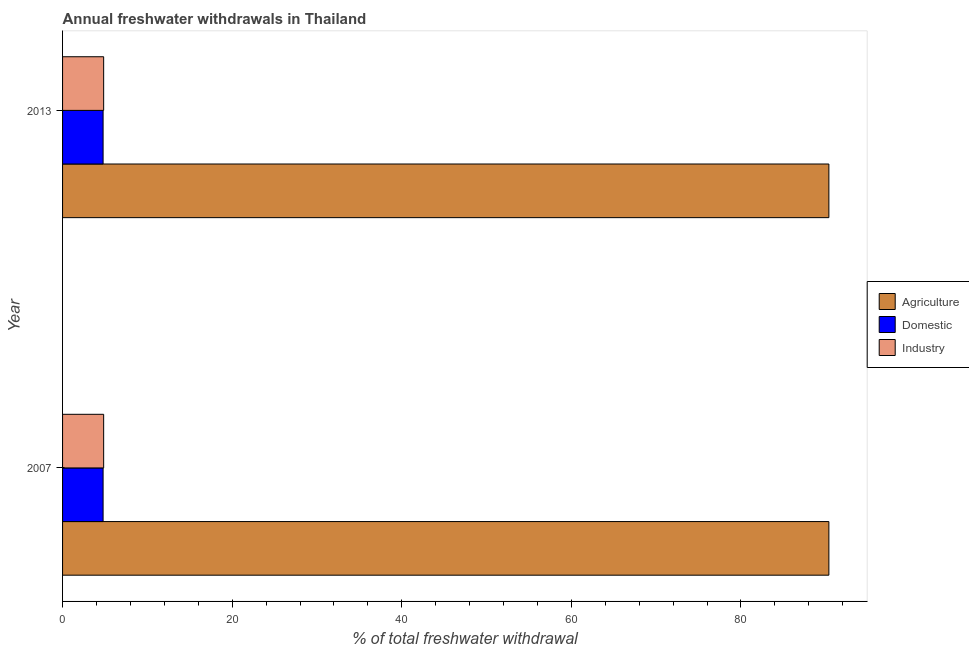Are the number of bars per tick equal to the number of legend labels?
Give a very brief answer. Yes. Are the number of bars on each tick of the Y-axis equal?
Offer a terse response. Yes. What is the percentage of freshwater withdrawal for agriculture in 2007?
Make the answer very short. 90.37. Across all years, what is the maximum percentage of freshwater withdrawal for domestic purposes?
Offer a very short reply. 4.78. Across all years, what is the minimum percentage of freshwater withdrawal for agriculture?
Make the answer very short. 90.37. In which year was the percentage of freshwater withdrawal for industry maximum?
Provide a short and direct response. 2007. What is the total percentage of freshwater withdrawal for domestic purposes in the graph?
Give a very brief answer. 9.56. What is the difference between the percentage of freshwater withdrawal for industry in 2007 and the percentage of freshwater withdrawal for domestic purposes in 2013?
Offer a very short reply. 0.07. What is the average percentage of freshwater withdrawal for agriculture per year?
Offer a very short reply. 90.37. In the year 2007, what is the difference between the percentage of freshwater withdrawal for industry and percentage of freshwater withdrawal for agriculture?
Keep it short and to the point. -85.52. In how many years, is the percentage of freshwater withdrawal for domestic purposes greater than 52 %?
Ensure brevity in your answer.  0. Is the percentage of freshwater withdrawal for domestic purposes in 2007 less than that in 2013?
Ensure brevity in your answer.  No. Is the difference between the percentage of freshwater withdrawal for domestic purposes in 2007 and 2013 greater than the difference between the percentage of freshwater withdrawal for industry in 2007 and 2013?
Provide a short and direct response. No. What does the 3rd bar from the top in 2013 represents?
Ensure brevity in your answer.  Agriculture. What does the 2nd bar from the bottom in 2007 represents?
Ensure brevity in your answer.  Domestic. Are all the bars in the graph horizontal?
Give a very brief answer. Yes. Are the values on the major ticks of X-axis written in scientific E-notation?
Make the answer very short. No. Where does the legend appear in the graph?
Provide a short and direct response. Center right. How many legend labels are there?
Your response must be concise. 3. What is the title of the graph?
Ensure brevity in your answer.  Annual freshwater withdrawals in Thailand. Does "Methane" appear as one of the legend labels in the graph?
Make the answer very short. No. What is the label or title of the X-axis?
Your response must be concise. % of total freshwater withdrawal. What is the label or title of the Y-axis?
Your answer should be very brief. Year. What is the % of total freshwater withdrawal of Agriculture in 2007?
Keep it short and to the point. 90.37. What is the % of total freshwater withdrawal in Domestic in 2007?
Give a very brief answer. 4.78. What is the % of total freshwater withdrawal in Industry in 2007?
Ensure brevity in your answer.  4.85. What is the % of total freshwater withdrawal in Agriculture in 2013?
Give a very brief answer. 90.37. What is the % of total freshwater withdrawal in Domestic in 2013?
Give a very brief answer. 4.78. What is the % of total freshwater withdrawal in Industry in 2013?
Offer a very short reply. 4.85. Across all years, what is the maximum % of total freshwater withdrawal in Agriculture?
Offer a terse response. 90.37. Across all years, what is the maximum % of total freshwater withdrawal in Domestic?
Provide a short and direct response. 4.78. Across all years, what is the maximum % of total freshwater withdrawal in Industry?
Offer a terse response. 4.85. Across all years, what is the minimum % of total freshwater withdrawal of Agriculture?
Your answer should be compact. 90.37. Across all years, what is the minimum % of total freshwater withdrawal in Domestic?
Make the answer very short. 4.78. Across all years, what is the minimum % of total freshwater withdrawal of Industry?
Make the answer very short. 4.85. What is the total % of total freshwater withdrawal of Agriculture in the graph?
Provide a short and direct response. 180.74. What is the total % of total freshwater withdrawal in Domestic in the graph?
Provide a short and direct response. 9.56. What is the total % of total freshwater withdrawal in Industry in the graph?
Provide a succinct answer. 9.69. What is the difference between the % of total freshwater withdrawal in Agriculture in 2007 and that in 2013?
Keep it short and to the point. 0. What is the difference between the % of total freshwater withdrawal of Domestic in 2007 and that in 2013?
Your answer should be compact. 0. What is the difference between the % of total freshwater withdrawal in Agriculture in 2007 and the % of total freshwater withdrawal in Domestic in 2013?
Make the answer very short. 85.59. What is the difference between the % of total freshwater withdrawal in Agriculture in 2007 and the % of total freshwater withdrawal in Industry in 2013?
Your answer should be compact. 85.52. What is the difference between the % of total freshwater withdrawal in Domestic in 2007 and the % of total freshwater withdrawal in Industry in 2013?
Make the answer very short. -0.07. What is the average % of total freshwater withdrawal in Agriculture per year?
Offer a very short reply. 90.37. What is the average % of total freshwater withdrawal in Domestic per year?
Offer a very short reply. 4.78. What is the average % of total freshwater withdrawal of Industry per year?
Keep it short and to the point. 4.85. In the year 2007, what is the difference between the % of total freshwater withdrawal in Agriculture and % of total freshwater withdrawal in Domestic?
Provide a succinct answer. 85.59. In the year 2007, what is the difference between the % of total freshwater withdrawal in Agriculture and % of total freshwater withdrawal in Industry?
Provide a short and direct response. 85.52. In the year 2007, what is the difference between the % of total freshwater withdrawal of Domestic and % of total freshwater withdrawal of Industry?
Provide a short and direct response. -0.07. In the year 2013, what is the difference between the % of total freshwater withdrawal in Agriculture and % of total freshwater withdrawal in Domestic?
Provide a succinct answer. 85.59. In the year 2013, what is the difference between the % of total freshwater withdrawal in Agriculture and % of total freshwater withdrawal in Industry?
Provide a short and direct response. 85.52. In the year 2013, what is the difference between the % of total freshwater withdrawal of Domestic and % of total freshwater withdrawal of Industry?
Offer a very short reply. -0.07. What is the ratio of the % of total freshwater withdrawal of Industry in 2007 to that in 2013?
Your response must be concise. 1. What is the difference between the highest and the second highest % of total freshwater withdrawal in Industry?
Ensure brevity in your answer.  0. What is the difference between the highest and the lowest % of total freshwater withdrawal in Agriculture?
Keep it short and to the point. 0. 